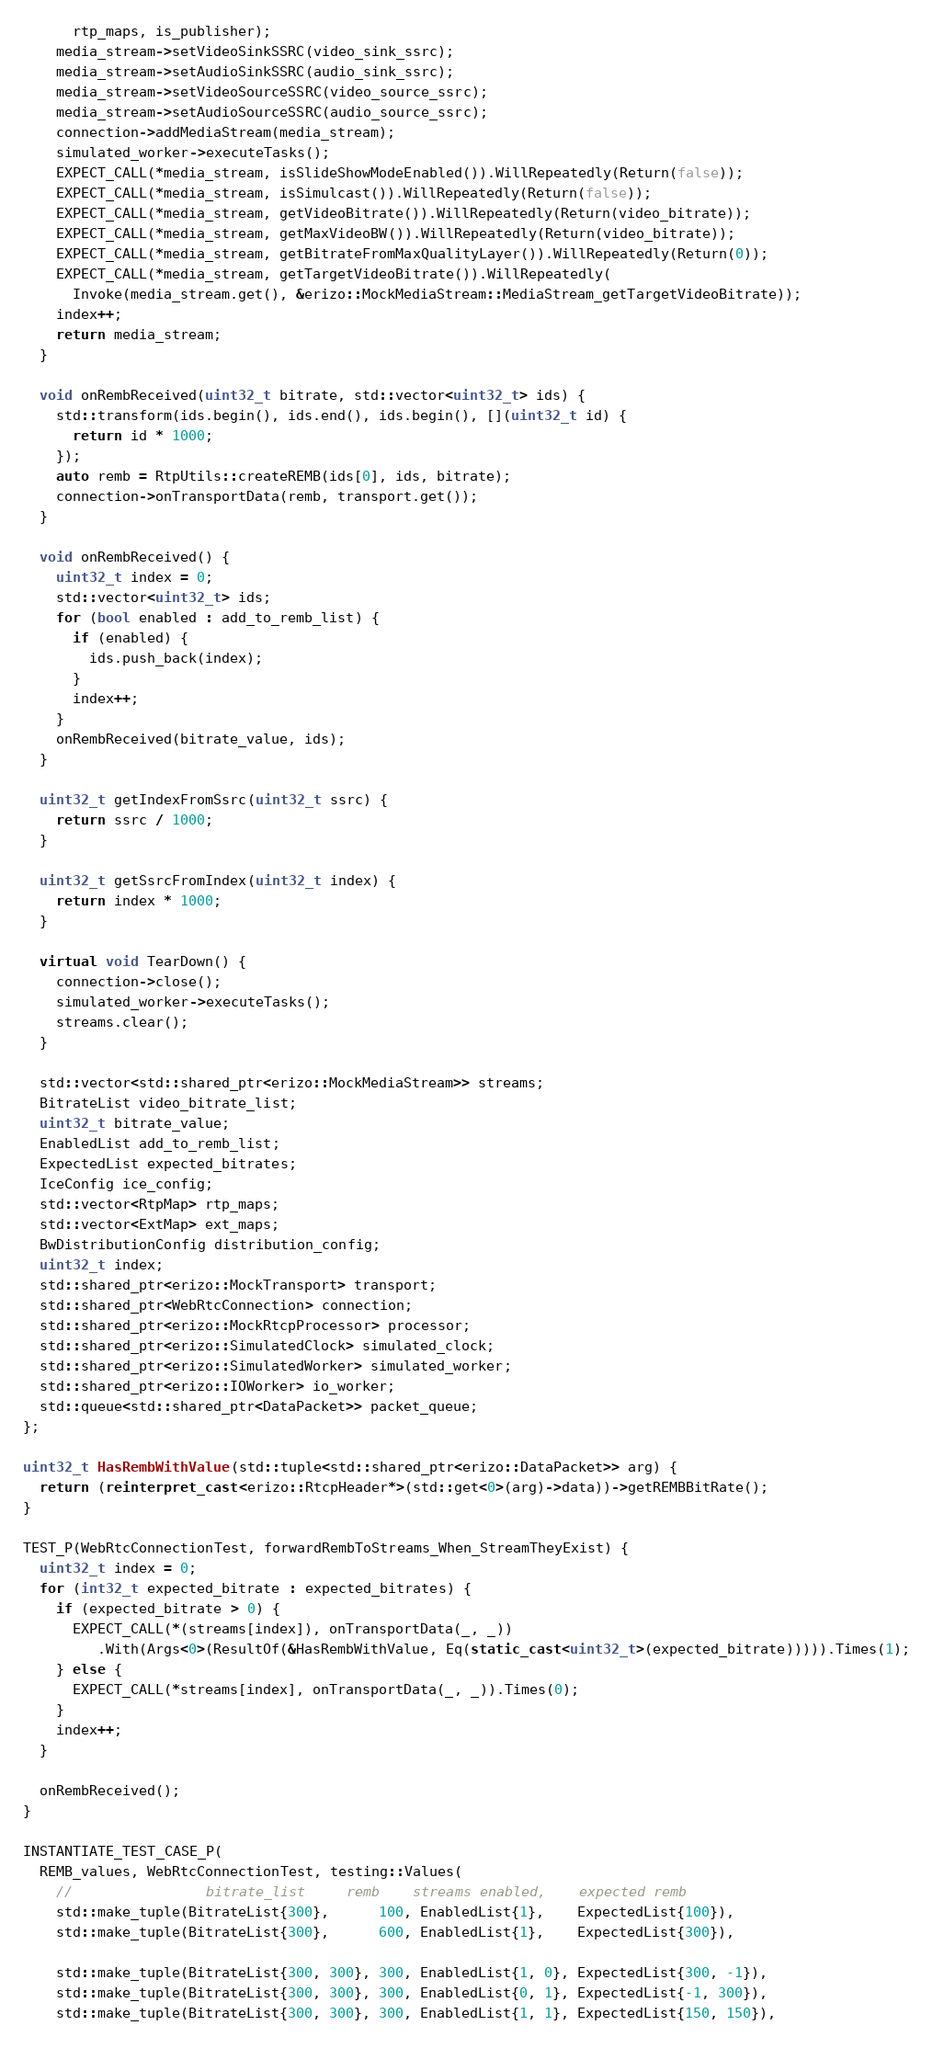<code> <loc_0><loc_0><loc_500><loc_500><_C++_>      rtp_maps, is_publisher);
    media_stream->setVideoSinkSSRC(video_sink_ssrc);
    media_stream->setAudioSinkSSRC(audio_sink_ssrc);
    media_stream->setVideoSourceSSRC(video_source_ssrc);
    media_stream->setAudioSourceSSRC(audio_source_ssrc);
    connection->addMediaStream(media_stream);
    simulated_worker->executeTasks();
    EXPECT_CALL(*media_stream, isSlideShowModeEnabled()).WillRepeatedly(Return(false));
    EXPECT_CALL(*media_stream, isSimulcast()).WillRepeatedly(Return(false));
    EXPECT_CALL(*media_stream, getVideoBitrate()).WillRepeatedly(Return(video_bitrate));
    EXPECT_CALL(*media_stream, getMaxVideoBW()).WillRepeatedly(Return(video_bitrate));
    EXPECT_CALL(*media_stream, getBitrateFromMaxQualityLayer()).WillRepeatedly(Return(0));
    EXPECT_CALL(*media_stream, getTargetVideoBitrate()).WillRepeatedly(
      Invoke(media_stream.get(), &erizo::MockMediaStream::MediaStream_getTargetVideoBitrate));
    index++;
    return media_stream;
  }

  void onRembReceived(uint32_t bitrate, std::vector<uint32_t> ids) {
    std::transform(ids.begin(), ids.end(), ids.begin(), [](uint32_t id) {
      return id * 1000;
    });
    auto remb = RtpUtils::createREMB(ids[0], ids, bitrate);
    connection->onTransportData(remb, transport.get());
  }

  void onRembReceived() {
    uint32_t index = 0;
    std::vector<uint32_t> ids;
    for (bool enabled : add_to_remb_list) {
      if (enabled) {
        ids.push_back(index);
      }
      index++;
    }
    onRembReceived(bitrate_value, ids);
  }

  uint32_t getIndexFromSsrc(uint32_t ssrc) {
    return ssrc / 1000;
  }

  uint32_t getSsrcFromIndex(uint32_t index) {
    return index * 1000;
  }

  virtual void TearDown() {
    connection->close();
    simulated_worker->executeTasks();
    streams.clear();
  }

  std::vector<std::shared_ptr<erizo::MockMediaStream>> streams;
  BitrateList video_bitrate_list;
  uint32_t bitrate_value;
  EnabledList add_to_remb_list;
  ExpectedList expected_bitrates;
  IceConfig ice_config;
  std::vector<RtpMap> rtp_maps;
  std::vector<ExtMap> ext_maps;
  BwDistributionConfig distribution_config;
  uint32_t index;
  std::shared_ptr<erizo::MockTransport> transport;
  std::shared_ptr<WebRtcConnection> connection;
  std::shared_ptr<erizo::MockRtcpProcessor> processor;
  std::shared_ptr<erizo::SimulatedClock> simulated_clock;
  std::shared_ptr<erizo::SimulatedWorker> simulated_worker;
  std::shared_ptr<erizo::IOWorker> io_worker;
  std::queue<std::shared_ptr<DataPacket>> packet_queue;
};

uint32_t HasRembWithValue(std::tuple<std::shared_ptr<erizo::DataPacket>> arg) {
  return (reinterpret_cast<erizo::RtcpHeader*>(std::get<0>(arg)->data))->getREMBBitRate();
}

TEST_P(WebRtcConnectionTest, forwardRembToStreams_When_StreamTheyExist) {
  uint32_t index = 0;
  for (int32_t expected_bitrate : expected_bitrates) {
    if (expected_bitrate > 0) {
      EXPECT_CALL(*(streams[index]), onTransportData(_, _))
         .With(Args<0>(ResultOf(&HasRembWithValue, Eq(static_cast<uint32_t>(expected_bitrate))))).Times(1);
    } else {
      EXPECT_CALL(*streams[index], onTransportData(_, _)).Times(0);
    }
    index++;
  }

  onRembReceived();
}

INSTANTIATE_TEST_CASE_P(
  REMB_values, WebRtcConnectionTest, testing::Values(
    //                bitrate_list     remb    streams enabled,    expected remb
    std::make_tuple(BitrateList{300},      100, EnabledList{1},    ExpectedList{100}),
    std::make_tuple(BitrateList{300},      600, EnabledList{1},    ExpectedList{300}),

    std::make_tuple(BitrateList{300, 300}, 300, EnabledList{1, 0}, ExpectedList{300, -1}),
    std::make_tuple(BitrateList{300, 300}, 300, EnabledList{0, 1}, ExpectedList{-1, 300}),
    std::make_tuple(BitrateList{300, 300}, 300, EnabledList{1, 1}, ExpectedList{150, 150}),</code> 